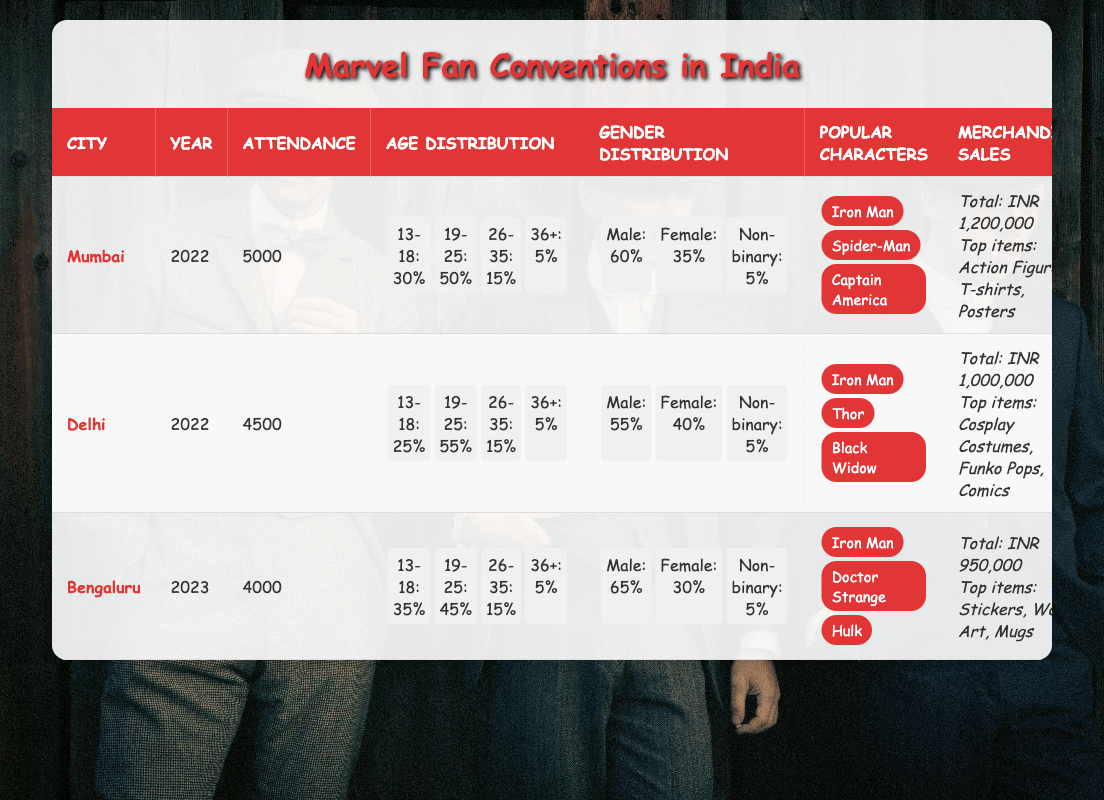What is the total attendance at Marvel Fan Conventions in Mumbai? The attendance in the Mumbai row of the table is listed directly under the Attendance column. It shows a value of 5000.
Answer: 5000 What are the popular characters at the Delhi convention? The popular characters for the Delhi convention are mentioned in the Popular Characters column. They include Iron Man, Thor, and Black Widow.
Answer: Iron Man, Thor, Black Widow How much merchandise was sold at the Bengaluru convention? The total merchandise sales at the Bengaluru convention can be found under the Merchandise Sales column. It states that the total sales were INR 950,000.
Answer: INR 950,000 What is the age distribution percentage for attendees aged 19-25 in Delhi? In the Delhi row under the Age Distribution column, the percentage for attendees aged 19-25 is specified as 55%.
Answer: 55% Which city had the highest percentage of male attendees? By comparing the Male percentages in the Gender Distribution per city, we see Mumbai has 60%, Delhi has 55%, and Bengaluru has 65%. Therefore, Bengaluru has the highest percentage of 65%.
Answer: Bengaluru What is the average percentage of attendees aged 36 and above across all conventions? The percentages for attendees aged 36+ are: Mumbai 5%, Delhi 5%, and Bengaluru 5%. The average is calculated as (5 + 5 + 5) / 3 = 5%.
Answer: 5% Does the merchandise sales total for Mumbai exceed Delhi's? We compare the total merchandise sales: Mumbai is INR 1,200,000 and Delhi is INR 1,000,000. Since 1,200,000 is greater than 1,000,000, the statement is true.
Answer: Yes What is the combined attendance for the conventions in Delhi and Bengaluru? By adding the attendance from Delhi (4500) and Bengaluru (4000), we calculate 4500 + 4000 = 8500.
Answer: 8500 Is Iron Man one of the most popular characters in all the conventions? Looking at each city’s popular characters, Iron Man appears in all of them (Mumbai, Delhi, and Bengaluru), indicating that it is indeed one of the most popular characters.
Answer: Yes Which city had the lowest total attendance? From the attendance data, Mumbai has 5000, Delhi has 4500, and Bengaluru has 4000. Bengaluru has the lowest attendance at 4000.
Answer: Bengaluru 